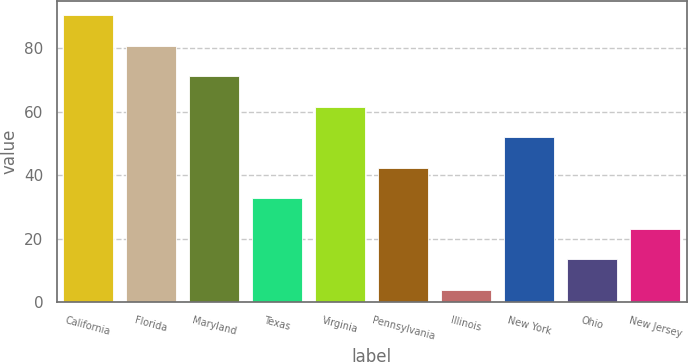<chart> <loc_0><loc_0><loc_500><loc_500><bar_chart><fcel>California<fcel>Florida<fcel>Maryland<fcel>Texas<fcel>Virginia<fcel>Pennsylvania<fcel>Illinois<fcel>New York<fcel>Ohio<fcel>New Jersey<nl><fcel>90.4<fcel>80.8<fcel>71.2<fcel>32.8<fcel>61.6<fcel>42.4<fcel>4<fcel>52<fcel>13.6<fcel>23.2<nl></chart> 